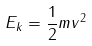<formula> <loc_0><loc_0><loc_500><loc_500>E _ { k } = \frac { 1 } { 2 } m v ^ { 2 }</formula> 